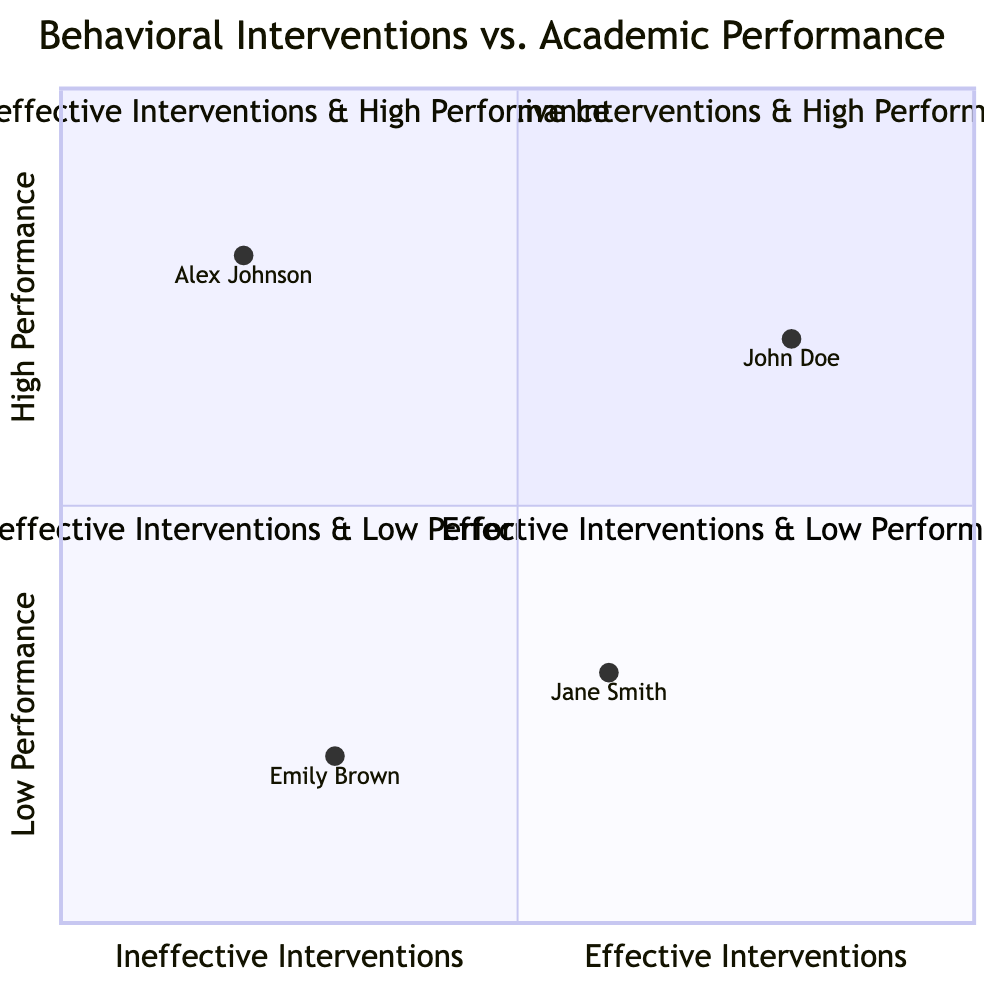What child is in the "Effective Interventions & High Performance" quadrant? The "Effective Interventions & High Performance" quadrant contains children who respond well to behavioral interventions and show high academic performance. Reviewing the data points, John Doe fits this description as he is noted with Applied Behavior Analysis and is above average in academic performance.
Answer: John Doe How many children are in the "Ineffective Interventions & Low Performance" quadrant? The "Ineffective Interventions & Low Performance" quadrant is identified by children who do not respond well to behavioral interventions and have low academic performance. By examining the data points, we find that only Emily Brown falls into this category. Hence, there is just one child in this quadrant.
Answer: 1 Which intervention is associated with the lowest academic performance? Looking at the "Effective Interventions & Low Performance" quadrant, Jane Smith utilizes Social Stories but has below-average academic performance. From evaluating the other children, Emily Brown also shows low performance with Cognitive Behavioral Therapy. Comparing both, Social Stories is associated specifically with Jane Smith, indicating a focus on those interventions.
Answer: Social Stories In which quadrant does Alex Johnson belong? Alex Johnson's description indicates that he does not respond well to the behavioral interventions yet still shows above-average academic performance. Therefore, this places him in the "Ineffective Interventions & High Performance" quadrant specifically due to his Positive Reinforcement intervention.
Answer: Ineffective Interventions & High Performance What is the behavioral intervention used by Emily Brown? By reviewing Emily Brown's data point, we see she is associated with Cognitive Behavioral Therapy (CBT) and also has below-average academic performance. Thus, the specific behavioral intervention used by her is clear from the data presented.
Answer: Cognitive Behavioral Therapy (CBT) 